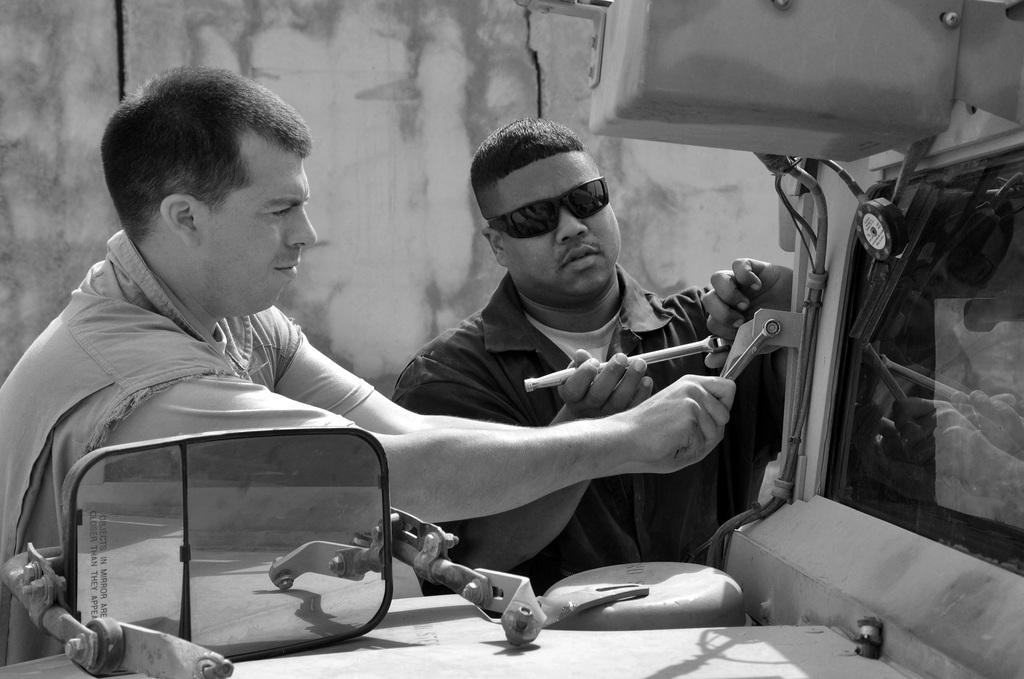How many people are present in the image? There are two persons in the image. What are the two persons doing in the image? The two persons are repairing a vehicle. Can you describe any specific part of the vehicle in the image? There is a mirror of a vehicle on the bonnet. What is the color scheme of the image? The image is in black and white. What can be seen in the background of the image? There is a wall in the background of the image. What type of lipstick is the person applying in the image? There is no person applying lipstick in the image; the two persons are repairing a vehicle. What kind of pot is being used to offer tea in the image? There is no pot or tea offering present in the image; the focus is on the vehicle repair. 